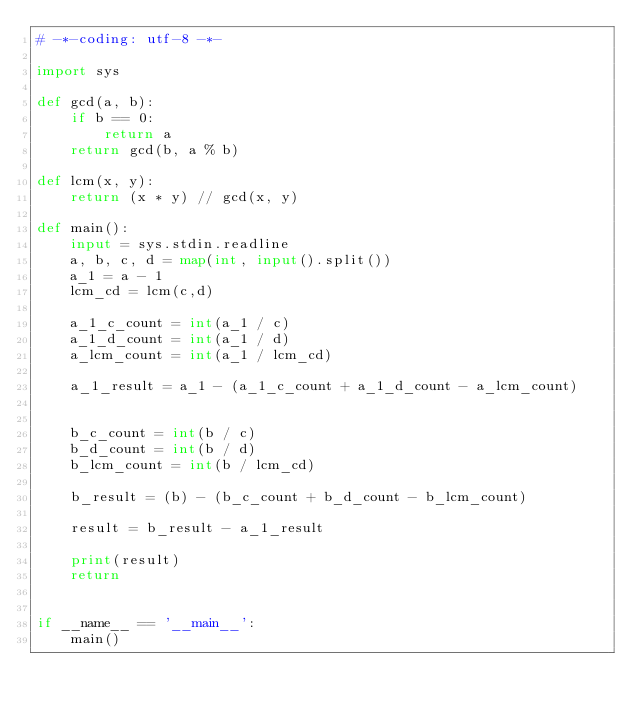Convert code to text. <code><loc_0><loc_0><loc_500><loc_500><_Python_># -*-coding: utf-8 -*-

import sys

def gcd(a, b):
    if b == 0: 
        return a
    return gcd(b, a % b)

def lcm(x, y):
    return (x * y) // gcd(x, y)

def main():
    input = sys.stdin.readline
    a, b, c, d = map(int, input().split())
    a_1 = a - 1
    lcm_cd = lcm(c,d)
    
    a_1_c_count = int(a_1 / c)
    a_1_d_count = int(a_1 / d)
    a_lcm_count = int(a_1 / lcm_cd)

    a_1_result = a_1 - (a_1_c_count + a_1_d_count - a_lcm_count)


    b_c_count = int(b / c)
    b_d_count = int(b / d)
    b_lcm_count = int(b / lcm_cd)

    b_result = (b) - (b_c_count + b_d_count - b_lcm_count)

    result = b_result - a_1_result

    print(result)
    return


if __name__ == '__main__':
    main()</code> 